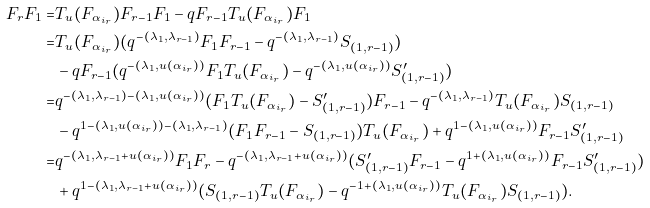Convert formula to latex. <formula><loc_0><loc_0><loc_500><loc_500>F _ { r } F _ { 1 } = & T _ { u } ( F _ { \alpha _ { i _ { r } } } ) F _ { r - 1 } F _ { 1 } - q F _ { r - 1 } T _ { u } ( F _ { \alpha _ { i _ { r } } } ) F _ { 1 } \\ = & T _ { u } ( F _ { \alpha _ { i _ { r } } } ) ( q ^ { - ( \lambda _ { 1 } , \lambda _ { r - 1 } ) } F _ { 1 } F _ { r - 1 } - q ^ { - ( \lambda _ { 1 } , \lambda _ { r - 1 } ) } S _ { ( 1 , r - 1 ) } ) \\ & - q F _ { r - 1 } ( q ^ { - ( \lambda _ { 1 } , u ( \alpha _ { i _ { r } } ) ) } F _ { 1 } T _ { u } ( F _ { \alpha _ { i _ { r } } } ) - q ^ { - ( \lambda _ { 1 } , u ( \alpha _ { i _ { r } } ) ) } S ^ { \prime } _ { ( 1 , r - 1 ) } ) \\ = & q ^ { - ( \lambda _ { 1 } , \lambda _ { r - 1 } ) - ( \lambda _ { 1 } , u ( \alpha _ { i _ { r } } ) ) } ( F _ { 1 } T _ { u } ( F _ { \alpha _ { i _ { r } } } ) - S ^ { \prime } _ { ( 1 , r - 1 ) } ) F _ { r - 1 } - q ^ { - ( \lambda _ { 1 } , \lambda _ { r - 1 } ) } T _ { u } ( F _ { \alpha _ { i _ { r } } } ) S _ { ( 1 , r - 1 ) } \\ & - q ^ { 1 - ( \lambda _ { 1 } , u ( \alpha _ { i _ { r } } ) ) - ( \lambda _ { 1 } , \lambda _ { r - 1 } ) } ( F _ { 1 } F _ { r - 1 } - S _ { ( 1 , r - 1 ) } ) T _ { u } ( F _ { \alpha _ { i _ { r } } } ) + q ^ { 1 - ( \lambda _ { 1 } , u ( \alpha _ { i _ { r } } ) ) } F _ { r - 1 } S ^ { \prime } _ { ( 1 , r - 1 ) } \\ = & q ^ { - ( \lambda _ { 1 } , \lambda _ { r - 1 } + u ( \alpha _ { i _ { r } } ) ) } F _ { 1 } F _ { r } - q ^ { - ( \lambda _ { 1 } , \lambda _ { r - 1 } + u ( \alpha _ { i _ { r } } ) ) } ( S ^ { \prime } _ { ( 1 , r - 1 ) } F _ { r - 1 } - q ^ { 1 + ( \lambda _ { 1 } , u ( \alpha _ { i _ { r } } ) ) } F _ { r - 1 } S ^ { \prime } _ { ( 1 , r - 1 ) } ) \\ & + q ^ { 1 - ( \lambda _ { 1 } , \lambda _ { r - 1 } + u ( \alpha _ { i _ { r } } ) ) } ( S _ { ( 1 , r - 1 ) } T _ { u } ( F _ { \alpha _ { i _ { r } } } ) - q ^ { - 1 + ( \lambda _ { 1 } , u ( \alpha _ { i _ { r } } ) ) } T _ { u } ( F _ { \alpha _ { i _ { r } } } ) S _ { ( 1 , r - 1 ) } ) .</formula> 